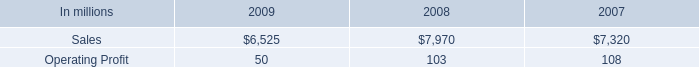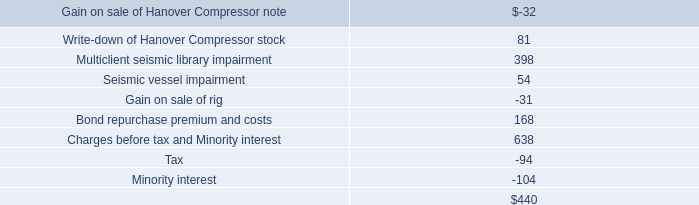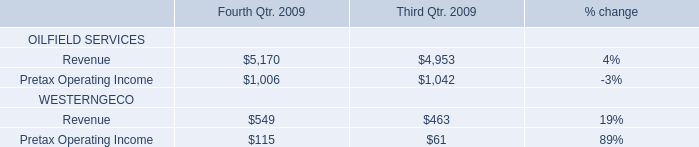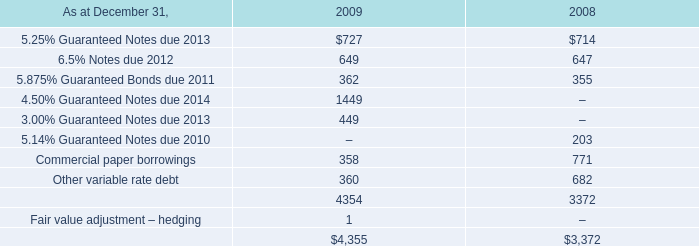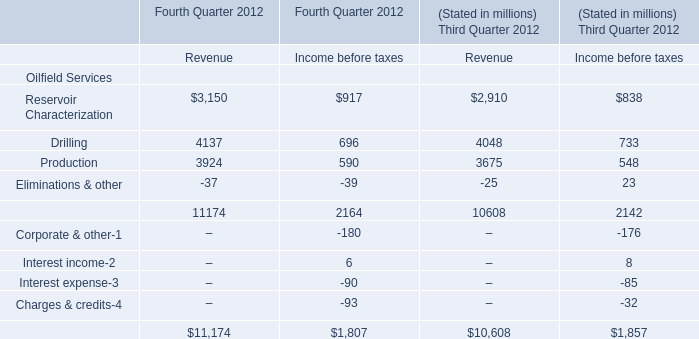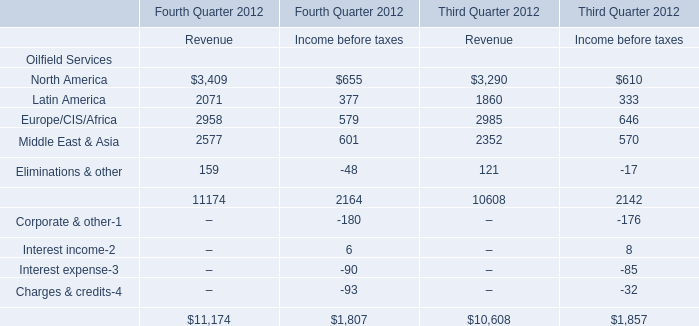What is the sum of Revenue in the range of 2000 and 3000 in 2012 for Third Quarter 2012? 
Computations: (2985 + 2352)
Answer: 5337.0. 